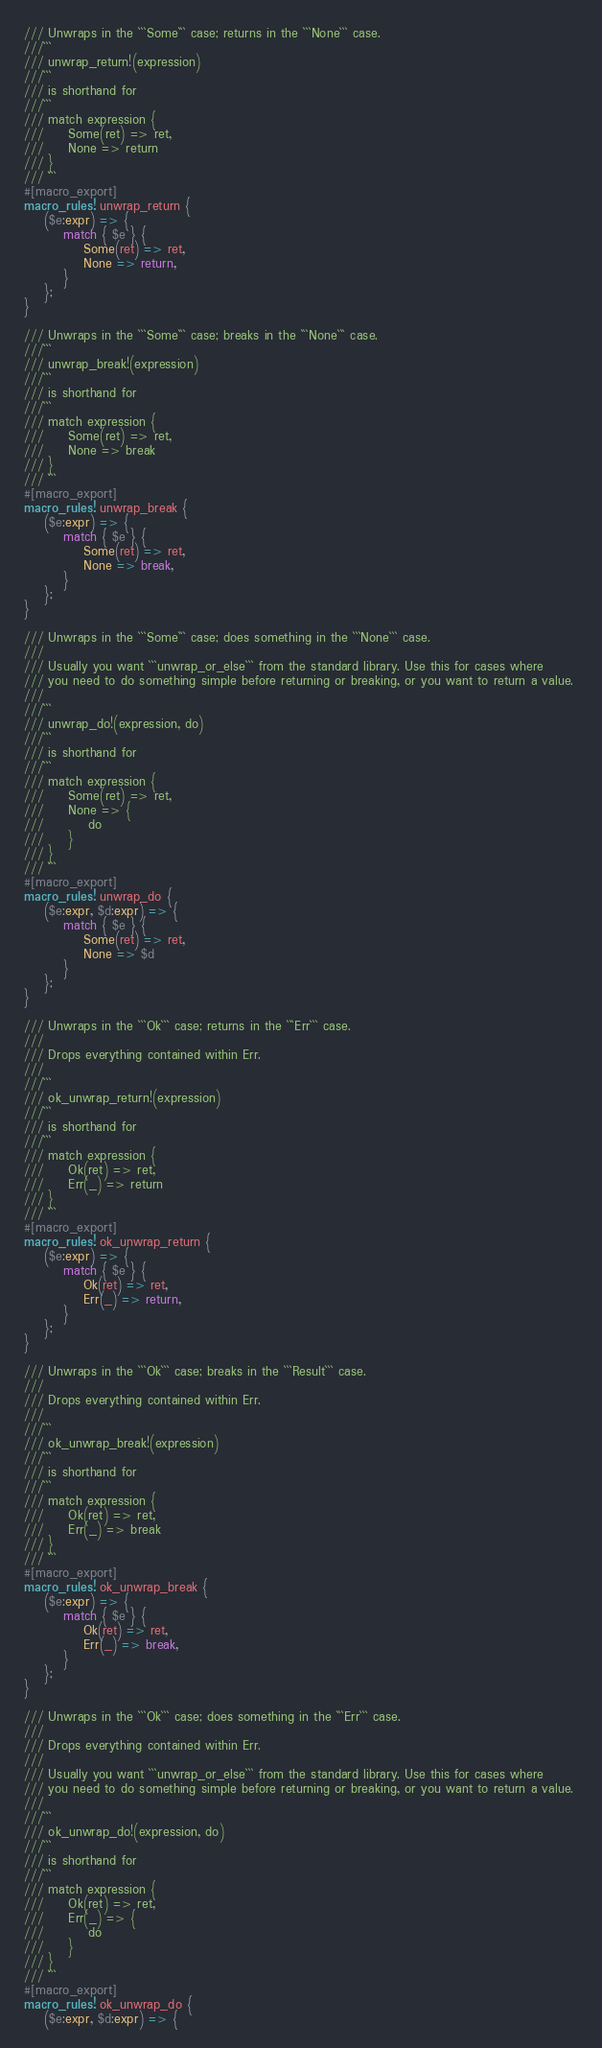Convert code to text. <code><loc_0><loc_0><loc_500><loc_500><_Rust_>/// Unwraps in the ```Some``` case; returns in the ```None``` case.
///```
/// unwrap_return!(expression)
///```
/// is shorthand for
///```
/// match expression {
///     Some(ret) => ret,
///     None => return
/// }
/// ```
#[macro_export]
macro_rules! unwrap_return {
    ($e:expr) => {
        match { $e } {
            Some(ret) => ret,
            None => return,
        }
    };
}

/// Unwraps in the ```Some``` case; breaks in the ```None``` case.
///```
/// unwrap_break!(expression)
///```
/// is shorthand for
///```
/// match expression {
///     Some(ret) => ret,
///     None => break
/// }
/// ```
#[macro_export]
macro_rules! unwrap_break {
    ($e:expr) => {
        match { $e } {
            Some(ret) => ret,
            None => break,
        }
    };
}

/// Unwraps in the ```Some``` case; does something in the ```None``` case.
///
/// Usually you want ```unwrap_or_else``` from the standard library. Use this for cases where 
/// you need to do something simple before returning or breaking, or you want to return a value. 
///
///```
/// unwrap_do!(expression, do)
///```
/// is shorthand for
///```
/// match expression {
///     Some(ret) => ret,
///     None => {
///         do
///     }
/// }
/// ```
#[macro_export]
macro_rules! unwrap_do {
    ($e:expr, $d:expr) => {
        match { $e } {
            Some(ret) => ret,
            None => $d
        }
    };
}

/// Unwraps in the ```Ok``` case; returns in the ```Err``` case.
///
/// Drops everything contained within Err.
///
///```
/// ok_unwrap_return!(expression)
///```
/// is shorthand for
///```
/// match expression {
///     Ok(ret) => ret,
///     Err(_) => return
/// }
/// ```
#[macro_export]
macro_rules! ok_unwrap_return {
    ($e:expr) => {
        match { $e } {
            Ok(ret) => ret,
            Err(_) => return,
        }
    };
}

/// Unwraps in the ```Ok``` case; breaks in the ```Result``` case.
///
/// Drops everything contained within Err.
///
///```
/// ok_unwrap_break!(expression)
///```
/// is shorthand for
///```
/// match expression {
///     Ok(ret) => ret,
///     Err(_) => break
/// }
/// ```
#[macro_export]
macro_rules! ok_unwrap_break {
    ($e:expr) => {
        match { $e } {
            Ok(ret) => ret,
            Err(_) => break,
        }
    };
}

/// Unwraps in the ```Ok``` case; does something in the ```Err``` case.
///
/// Drops everything contained within Err.
///
/// Usually you want ```unwrap_or_else``` from the standard library. Use this for cases where 
/// you need to do something simple before returning or breaking, or you want to return a value.
///
///```
/// ok_unwrap_do!(expression, do)
///```
/// is shorthand for
///```
/// match expression {
///     Ok(ret) => ret,
///     Err(_) => {
///         do
///     }
/// }
/// ```
#[macro_export]
macro_rules! ok_unwrap_do {
    ($e:expr, $d:expr) => {</code> 